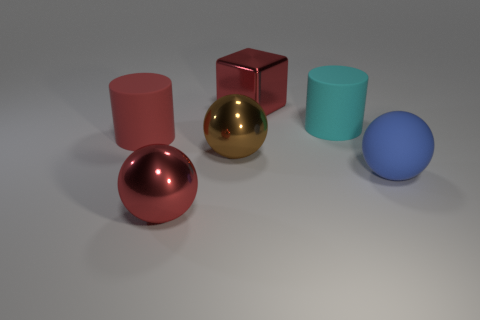Is the number of large brown objects in front of the big blue sphere greater than the number of large objects that are to the left of the red metal ball?
Your answer should be very brief. No. Do the large brown ball and the large red object that is in front of the big red rubber cylinder have the same material?
Your answer should be compact. Yes. What color is the large block?
Your answer should be compact. Red. The large shiny object to the right of the big brown metallic object has what shape?
Give a very brief answer. Cube. How many green objects are big shiny objects or big matte objects?
Offer a terse response. 0. There is another large cylinder that is the same material as the red cylinder; what is its color?
Ensure brevity in your answer.  Cyan. Is the color of the block the same as the big rubber object left of the cyan object?
Keep it short and to the point. Yes. There is a big thing that is to the right of the brown metallic sphere and to the left of the cyan rubber cylinder; what color is it?
Make the answer very short. Red. There is a brown metal object; what number of big matte spheres are left of it?
Offer a very short reply. 0. How many objects are either blue metal cubes or blue objects on the right side of the cube?
Give a very brief answer. 1. 